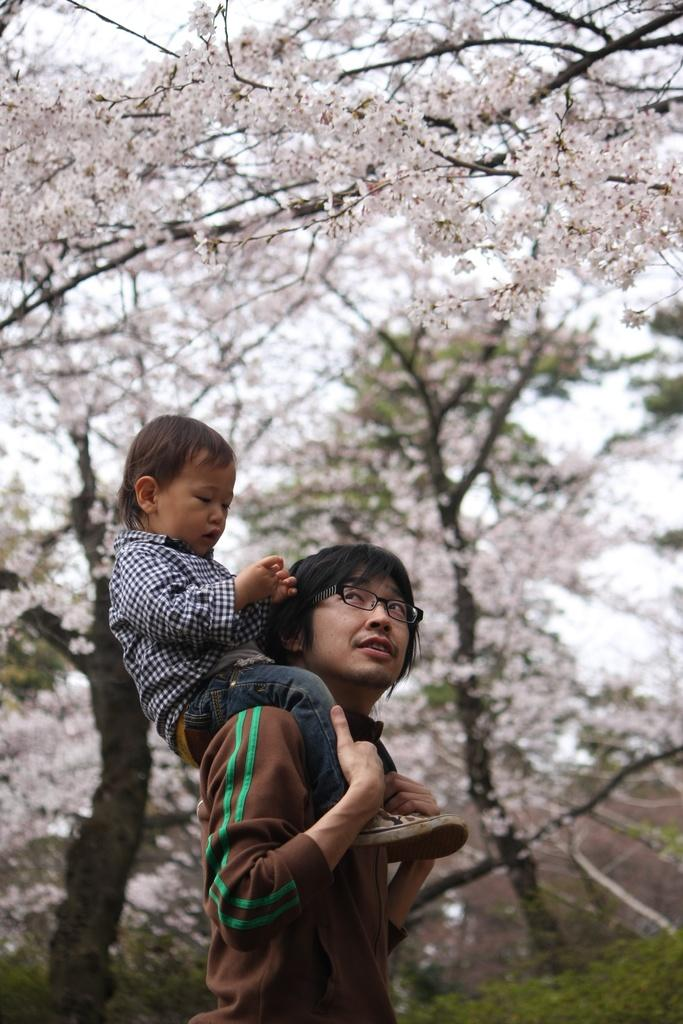Who is the main subject in the image? There is a boy in the image. What is the boy doing in the image? The boy is sitting on a man's shoulders. What type of natural environment can be seen in the image? There are trees visible in the image. What is visible in the background of the image? The sky is visible in the background of the image. What type of drum can be seen in the image? There is no drum present in the image. How long does the boy need to rest after sitting on the man's shoulders? The image does not provide information about how long the boy needs to rest, as it only shows a snapshot of the moment. 